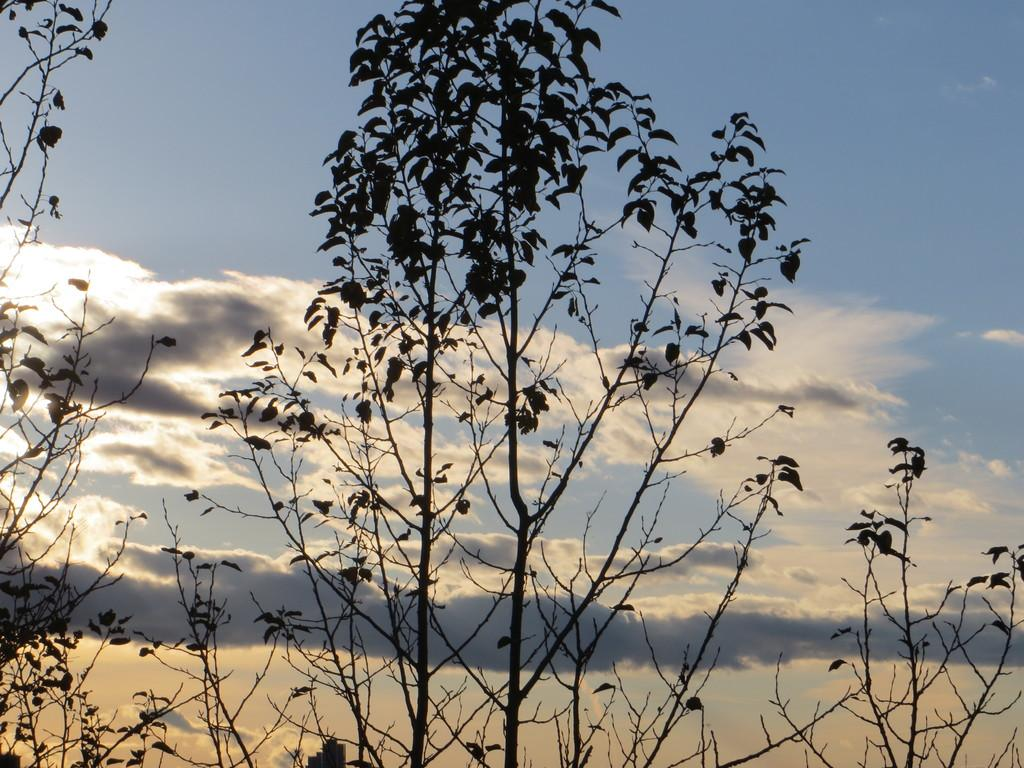What type of vegetation can be seen in the image? There are trees in the image. What is visible in the sky in the background of the image? There are clouds in the sky in the background of the image. What type of voyage is depicted in the image? There is no voyage depicted in the image; it features trees and clouds in the sky. What is located at the back of the image? The term "back" is not relevant to the image, as it is a two-dimensional representation. The image only has a left and right side, as well as a top and bottom. 